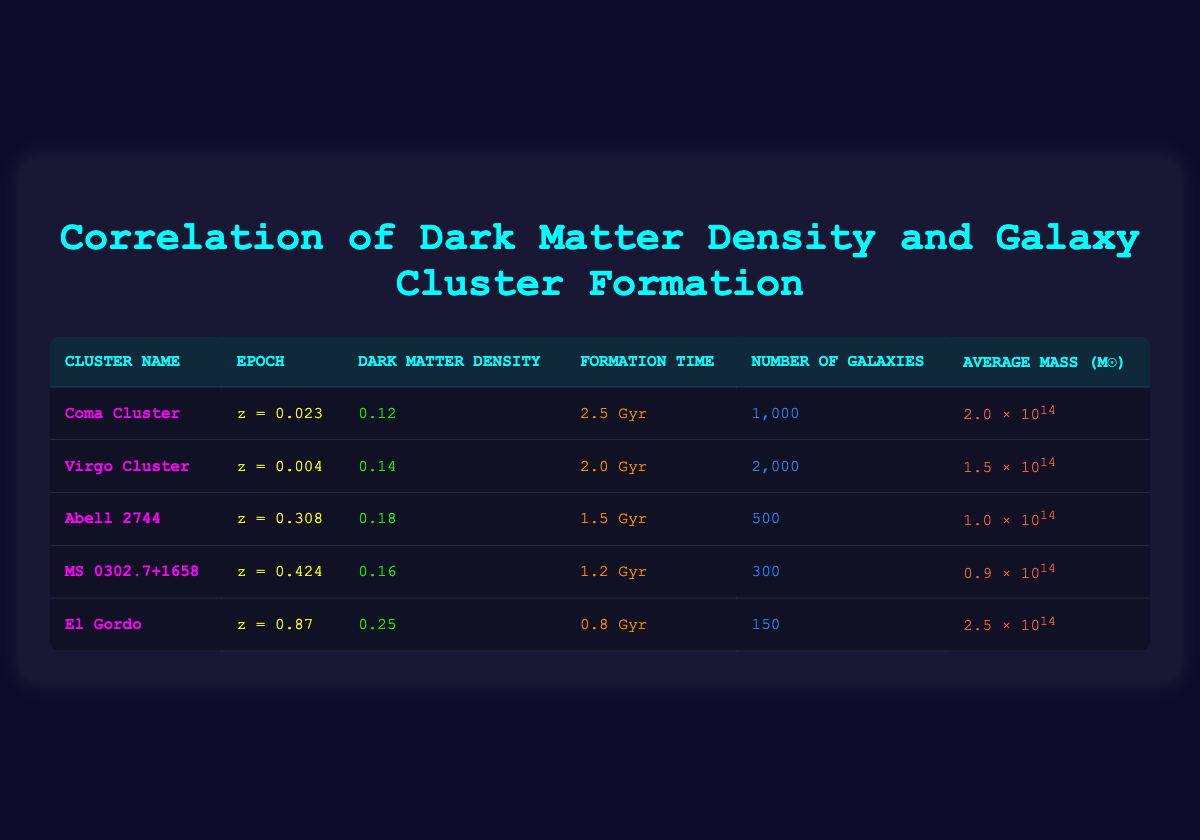What is the dark matter density of the Coma Cluster? The table clearly states that the dark matter density for the Coma Cluster is 0.12.
Answer: 0.12 How many galaxies are in the Virgo Cluster? According to the table, the Virgo Cluster has 2,000 galaxies listed.
Answer: 2,000 What is the average dark matter density of all clusters listed? To find the average, add the dark matter densities: 0.12 + 0.14 + 0.18 + 0.16 + 0.25 = 0.85. Then divide by the number of clusters (5): 0.85 / 5 = 0.17.
Answer: 0.17 Is the formation time for El Gordo shorter than that of Abell 2744? For El Gordo, the formation time is 0.8 Gyr and for Abell 2744 it is 1.5 Gyr. Since 0.8 Gyr is less than 1.5 Gyr, the statement is true.
Answer: Yes What is the difference in the average mass between the El Gordo and MS 0302.7+1658 clusters? The average mass for El Gordo is 2.5e14 and for MS 0302.7+1658 is 0.9e14. The difference is 2.5e14 - 0.9e14 = 1.6e14.
Answer: 1.6e14 Which cluster has the highest number of galaxies, and what is that number? Scanning through the table, the Virgo Cluster has the highest number of galaxies, totaling 2,000.
Answer: 2,000 What epoch corresponds to the lowest dark matter density? Looking through the dark matter densities, the Coma Cluster has the lowest density at 0.12. The epoch for this cluster is z = 0.023.
Answer: z = 0.023 If you sum the dark matter densities of all clusters, what would that total be? The total of the dark matter densities: 0.12 + 0.14 + 0.18 + 0.16 + 0.25 = 0.85.
Answer: 0.85 Is it true that the formation time for clusters decreases as the dark matter density increases? Reviewing the data, El Gordo, which has the highest dark matter density of 0.25, has the shortest formation time of 0.8 Gyr, supporting this trend. Therefore, the statement is true.
Answer: Yes 